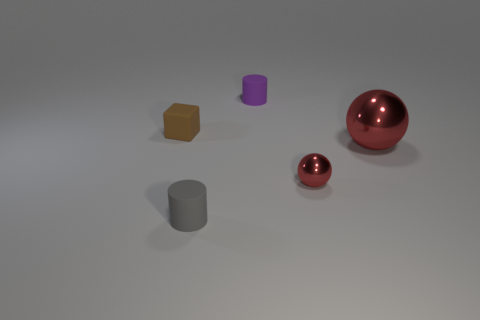Add 2 purple matte cylinders. How many objects exist? 7 Subtract all cylinders. How many objects are left? 3 Subtract all tiny brown matte things. Subtract all small red metallic things. How many objects are left? 3 Add 3 tiny purple matte cylinders. How many tiny purple matte cylinders are left? 4 Add 1 purple cylinders. How many purple cylinders exist? 2 Subtract 1 brown blocks. How many objects are left? 4 